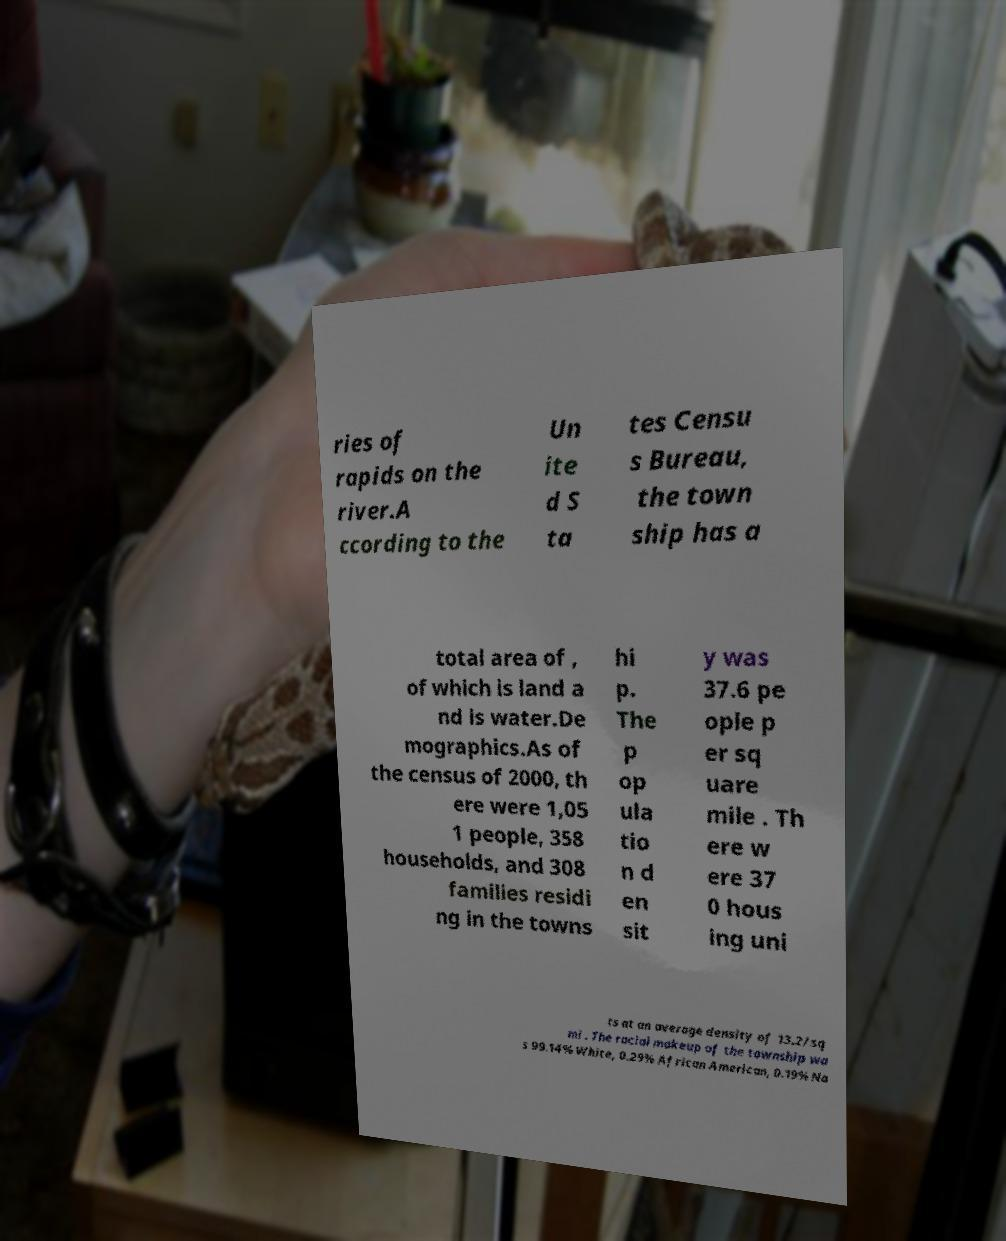Could you assist in decoding the text presented in this image and type it out clearly? ries of rapids on the river.A ccording to the Un ite d S ta tes Censu s Bureau, the town ship has a total area of , of which is land a nd is water.De mographics.As of the census of 2000, th ere were 1,05 1 people, 358 households, and 308 families residi ng in the towns hi p. The p op ula tio n d en sit y was 37.6 pe ople p er sq uare mile . Th ere w ere 37 0 hous ing uni ts at an average density of 13.2/sq mi . The racial makeup of the township wa s 99.14% White, 0.29% African American, 0.19% Na 